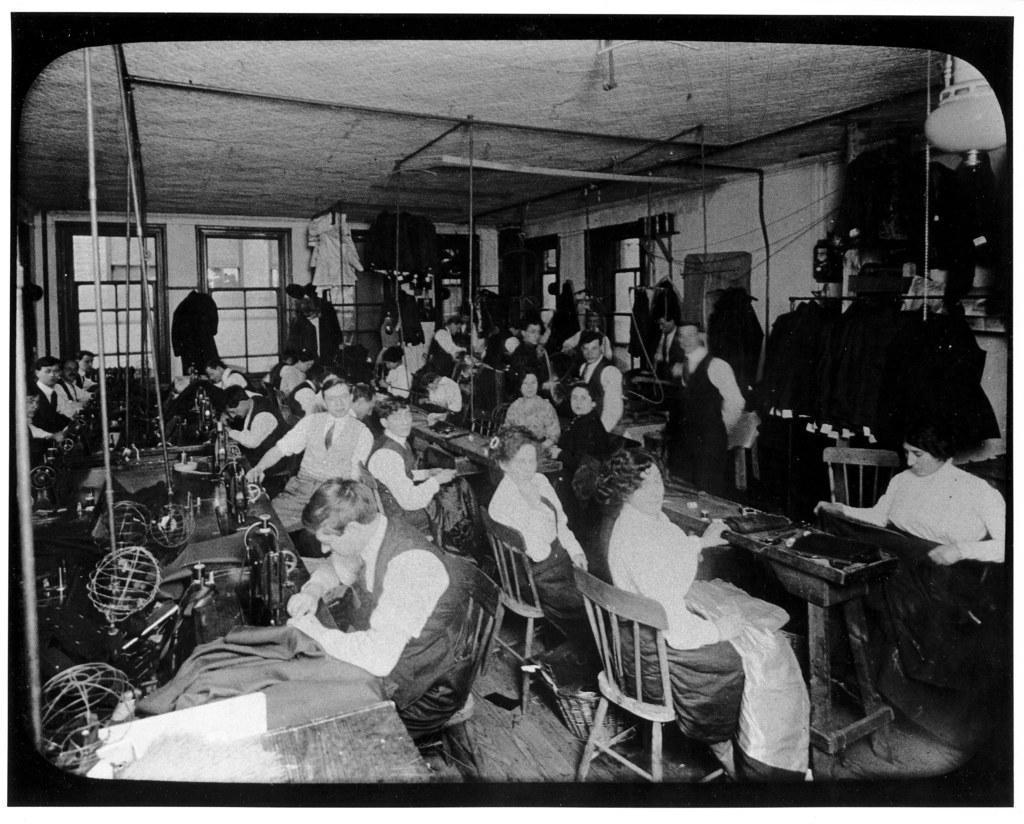Could you give a brief overview of what you see in this image? It looks like an old black and white picture. We can see there are groups of people sitting on chairs and doing some work and in front of the people there are table and on the tables there are some machine. Behind the people, there is a wall and cables. 